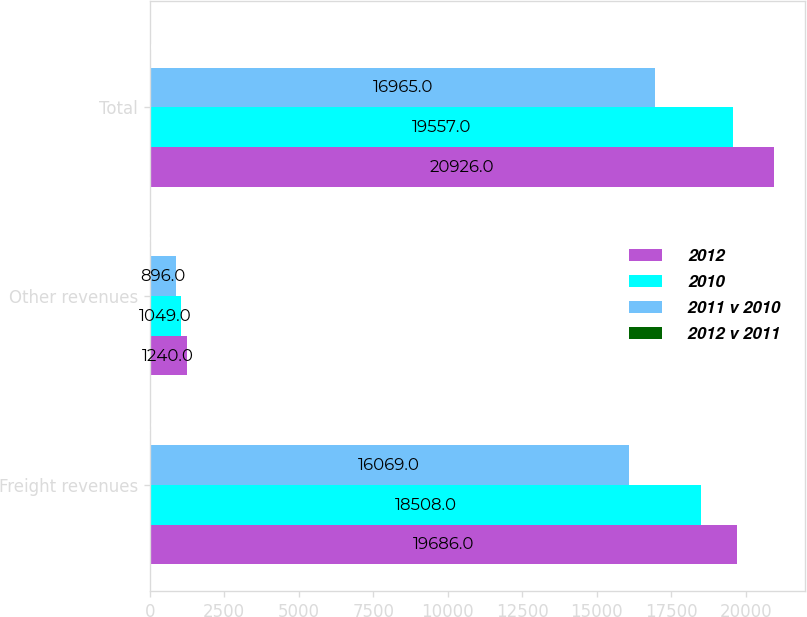Convert chart. <chart><loc_0><loc_0><loc_500><loc_500><stacked_bar_chart><ecel><fcel>Freight revenues<fcel>Other revenues<fcel>Total<nl><fcel>2012<fcel>19686<fcel>1240<fcel>20926<nl><fcel>2010<fcel>18508<fcel>1049<fcel>19557<nl><fcel>2011 v 2010<fcel>16069<fcel>896<fcel>16965<nl><fcel>2012 v 2011<fcel>6<fcel>18<fcel>7<nl></chart> 